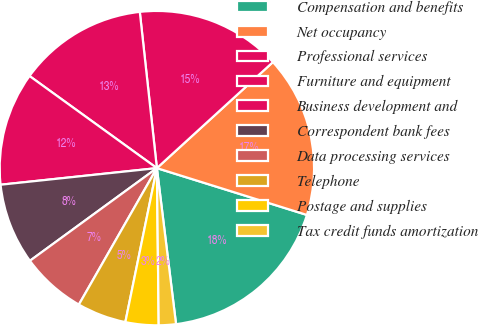Convert chart to OTSL. <chart><loc_0><loc_0><loc_500><loc_500><pie_chart><fcel>Compensation and benefits<fcel>Net occupancy<fcel>Professional services<fcel>Furniture and equipment<fcel>Business development and<fcel>Correspondent bank fees<fcel>Data processing services<fcel>Telephone<fcel>Postage and supplies<fcel>Tax credit funds amortization<nl><fcel>18.24%<fcel>16.6%<fcel>14.95%<fcel>13.3%<fcel>11.65%<fcel>8.35%<fcel>6.7%<fcel>5.05%<fcel>3.4%<fcel>1.76%<nl></chart> 